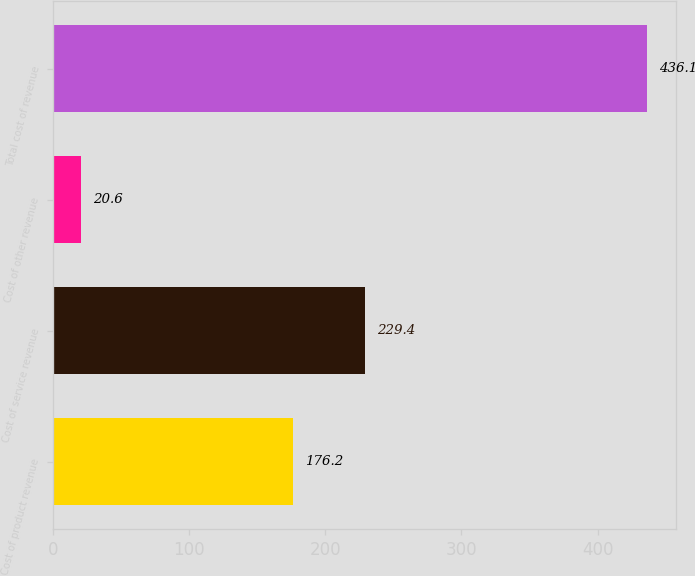<chart> <loc_0><loc_0><loc_500><loc_500><bar_chart><fcel>Cost of product revenue<fcel>Cost of service revenue<fcel>Cost of other revenue<fcel>Total cost of revenue<nl><fcel>176.2<fcel>229.4<fcel>20.6<fcel>436.1<nl></chart> 